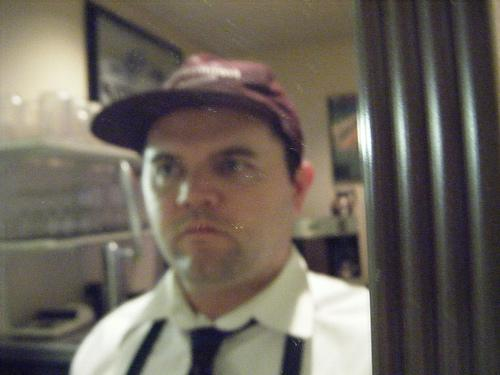Based on the image, how many items of clothing is the man wearing and what are their colors? The man is wearing three items of clothing: a white shirt, a black tie, and a red hat. What is the most distinctive feature of the man's outfit in this image? The most distinctive feature of the man's outfit is his red hat. Can you infer if the man has a specific role within the restaurant? If so, what is it? The man might be a bus boy or a restaurant worker in uniform since he is dressed in a white shirt, black tie, apron, and a red hat. Determine whether the person in the image is wearing any accessories, and if so, provide a brief description. Yes, the man is wearing a black tie as an accessory. What common task might this individual be responsible for within a restaurant setting? The man might be responsible for clearing tables, serving food, or attending to customers' needs within the restaurant setting. What is the color of the cap being worn by the man in the image? The man is wearing a red-colored cap. Identify an object in the image that is not part of the man's attire but could be confused as part of a background. There are red and silver trains on tracks which could be confused as part of a background rather than the man's attire. Refer to a specific part of the person's attire in the image that is typically associated with formal settings. The black tie worn by the man is often associated with formal settings. What is the color and pattern of the man's shirt, and what are some facial features that can be identified from the image? The man is wearing a white shirt with no discernible pattern. His mouth, ear, and light-skinned complexion can be identified based on the image. Identify the profession of the individual in the image and describe their attire. The person is a restaurant worker wearing a white shirt, black tie, apron, and a red hat as part of their uniform. 